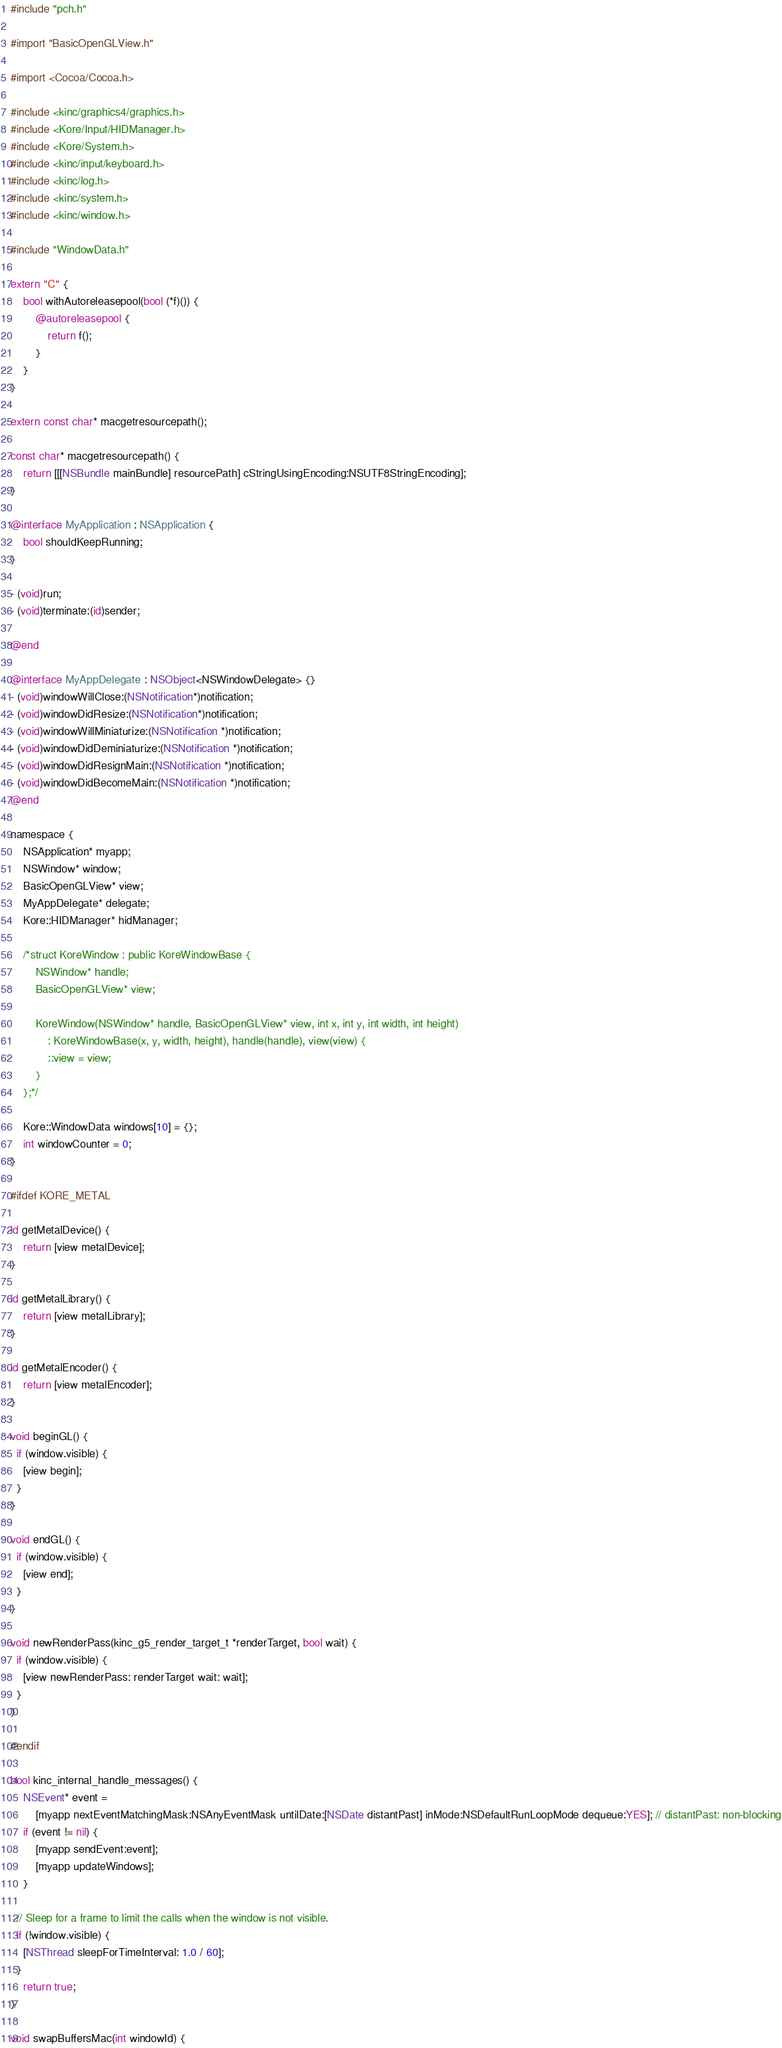<code> <loc_0><loc_0><loc_500><loc_500><_ObjectiveC_>#include "pch.h"

#import "BasicOpenGLView.h"

#import <Cocoa/Cocoa.h>

#include <kinc/graphics4/graphics.h>
#include <Kore/Input/HIDManager.h>
#include <Kore/System.h>
#include <kinc/input/keyboard.h>
#include <kinc/log.h>
#include <kinc/system.h>
#include <kinc/window.h>

#include "WindowData.h"

extern "C" {
	bool withAutoreleasepool(bool (*f)()) {
		@autoreleasepool {
			return f();
		}
	}
}

extern const char* macgetresourcepath();

const char* macgetresourcepath() {
	return [[[NSBundle mainBundle] resourcePath] cStringUsingEncoding:NSUTF8StringEncoding];
}

@interface MyApplication : NSApplication {
	bool shouldKeepRunning;
}

- (void)run;
- (void)terminate:(id)sender;

@end

@interface MyAppDelegate : NSObject<NSWindowDelegate> {}
- (void)windowWillClose:(NSNotification*)notification;
- (void)windowDidResize:(NSNotification*)notification;
- (void)windowWillMiniaturize:(NSNotification *)notification;
- (void)windowDidDeminiaturize:(NSNotification *)notification;
- (void)windowDidResignMain:(NSNotification *)notification;
- (void)windowDidBecomeMain:(NSNotification *)notification;
@end

namespace {
	NSApplication* myapp;
	NSWindow* window;
	BasicOpenGLView* view;
	MyAppDelegate* delegate;
	Kore::HIDManager* hidManager;

	/*struct KoreWindow : public KoreWindowBase {
		NSWindow* handle;
		BasicOpenGLView* view;

		KoreWindow(NSWindow* handle, BasicOpenGLView* view, int x, int y, int width, int height)
		    : KoreWindowBase(x, y, width, height), handle(handle), view(view) {
			::view = view;
		}
	};*/

	Kore::WindowData windows[10] = {};
	int windowCounter = 0;
}

#ifdef KORE_METAL

id getMetalDevice() {
	return [view metalDevice];
}

id getMetalLibrary() {
	return [view metalLibrary];
}

id getMetalEncoder() {
	return [view metalEncoder];
}

void beginGL() {
  if (window.visible) {
    [view begin];
  }
}

void endGL() {
  if (window.visible) {
    [view end];
  }
}

void newRenderPass(kinc_g5_render_target_t *renderTarget, bool wait) {
  if (window.visible) {
    [view newRenderPass: renderTarget wait: wait];
  }
}

#endif

bool kinc_internal_handle_messages() {
	NSEvent* event =
	    [myapp nextEventMatchingMask:NSAnyEventMask untilDate:[NSDate distantPast] inMode:NSDefaultRunLoopMode dequeue:YES]; // distantPast: non-blocking
	if (event != nil) {
		[myapp sendEvent:event];
		[myapp updateWindows];
	}
  
  // Sleep for a frame to limit the calls when the window is not visible.
  if (!window.visible) {
    [NSThread sleepForTimeInterval: 1.0 / 60];
  }
	return true;
}

void swapBuffersMac(int windowId) {</code> 